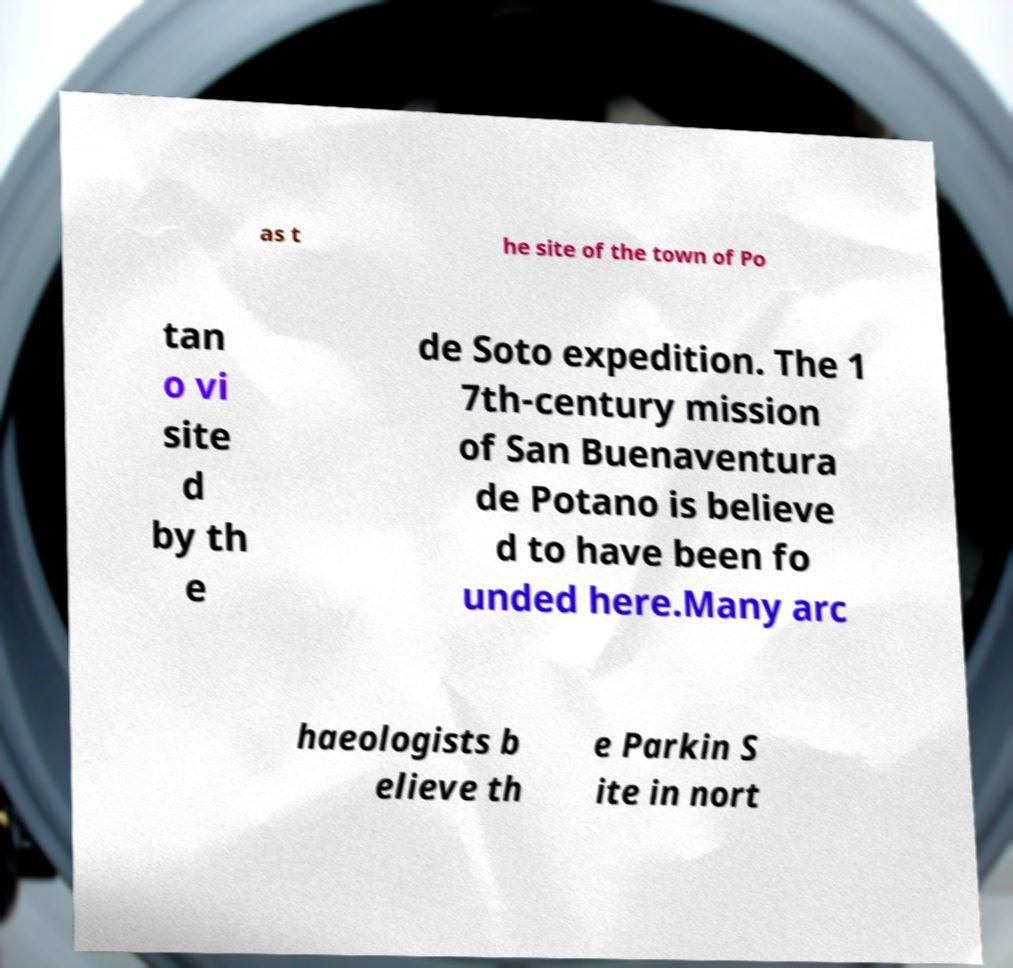Could you extract and type out the text from this image? as t he site of the town of Po tan o vi site d by th e de Soto expedition. The 1 7th-century mission of San Buenaventura de Potano is believe d to have been fo unded here.Many arc haeologists b elieve th e Parkin S ite in nort 